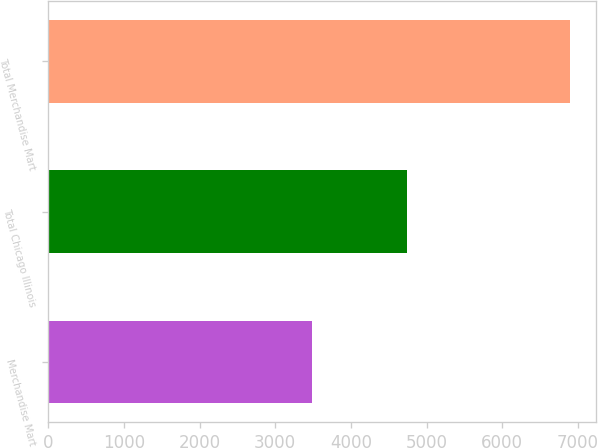Convert chart. <chart><loc_0><loc_0><loc_500><loc_500><bar_chart><fcel>Merchandise Mart<fcel>Total Chicago Illinois<fcel>Total Merchandise Mart<nl><fcel>3492<fcel>4744<fcel>6893<nl></chart> 